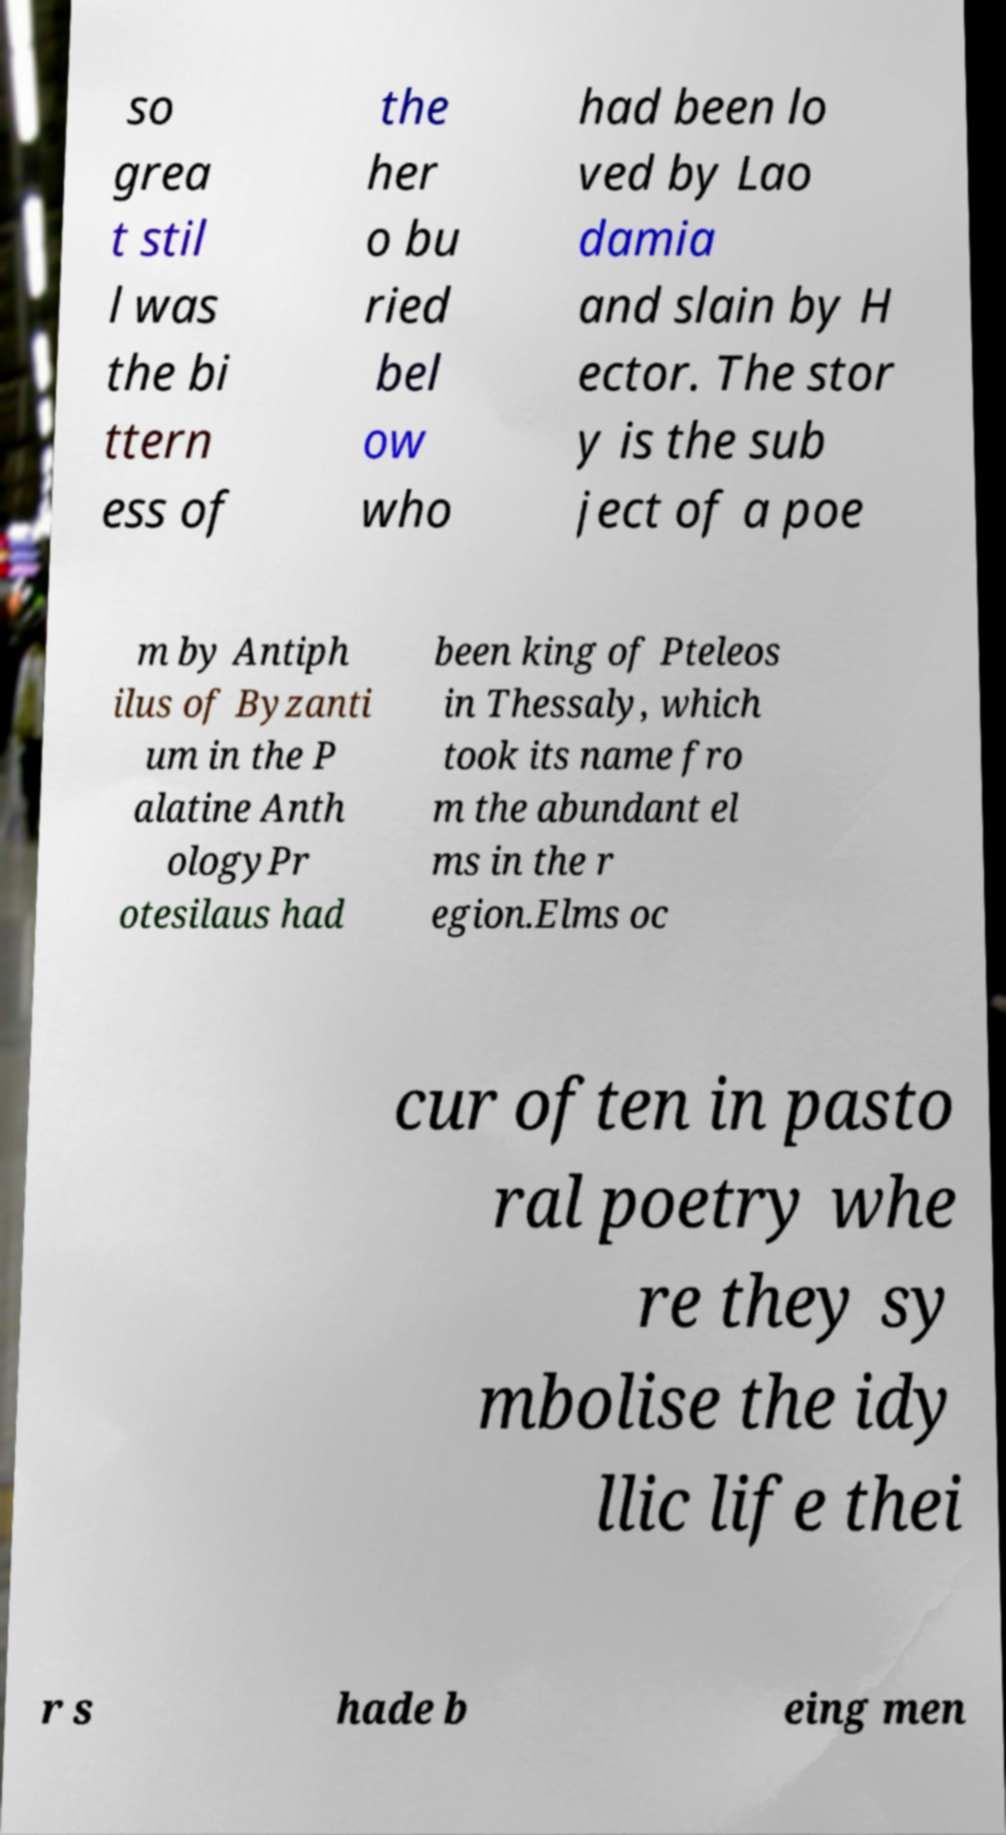What messages or text are displayed in this image? I need them in a readable, typed format. so grea t stil l was the bi ttern ess of the her o bu ried bel ow who had been lo ved by Lao damia and slain by H ector. The stor y is the sub ject of a poe m by Antiph ilus of Byzanti um in the P alatine Anth ologyPr otesilaus had been king of Pteleos in Thessaly, which took its name fro m the abundant el ms in the r egion.Elms oc cur often in pasto ral poetry whe re they sy mbolise the idy llic life thei r s hade b eing men 